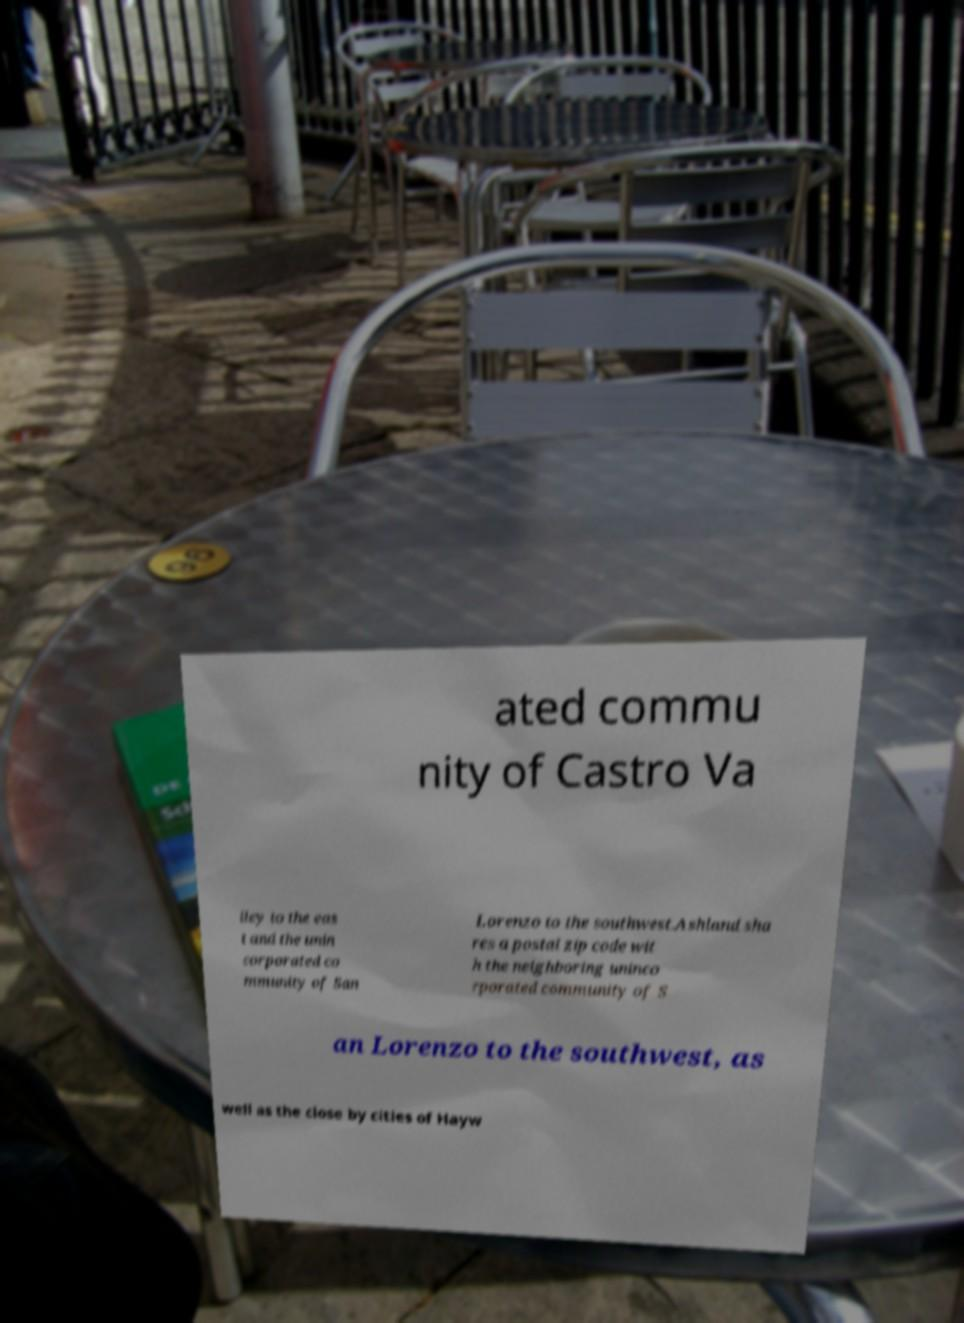Can you read and provide the text displayed in the image?This photo seems to have some interesting text. Can you extract and type it out for me? ated commu nity of Castro Va lley to the eas t and the unin corporated co mmunity of San Lorenzo to the southwest.Ashland sha res a postal zip code wit h the neighboring uninco rporated community of S an Lorenzo to the southwest, as well as the close by cities of Hayw 